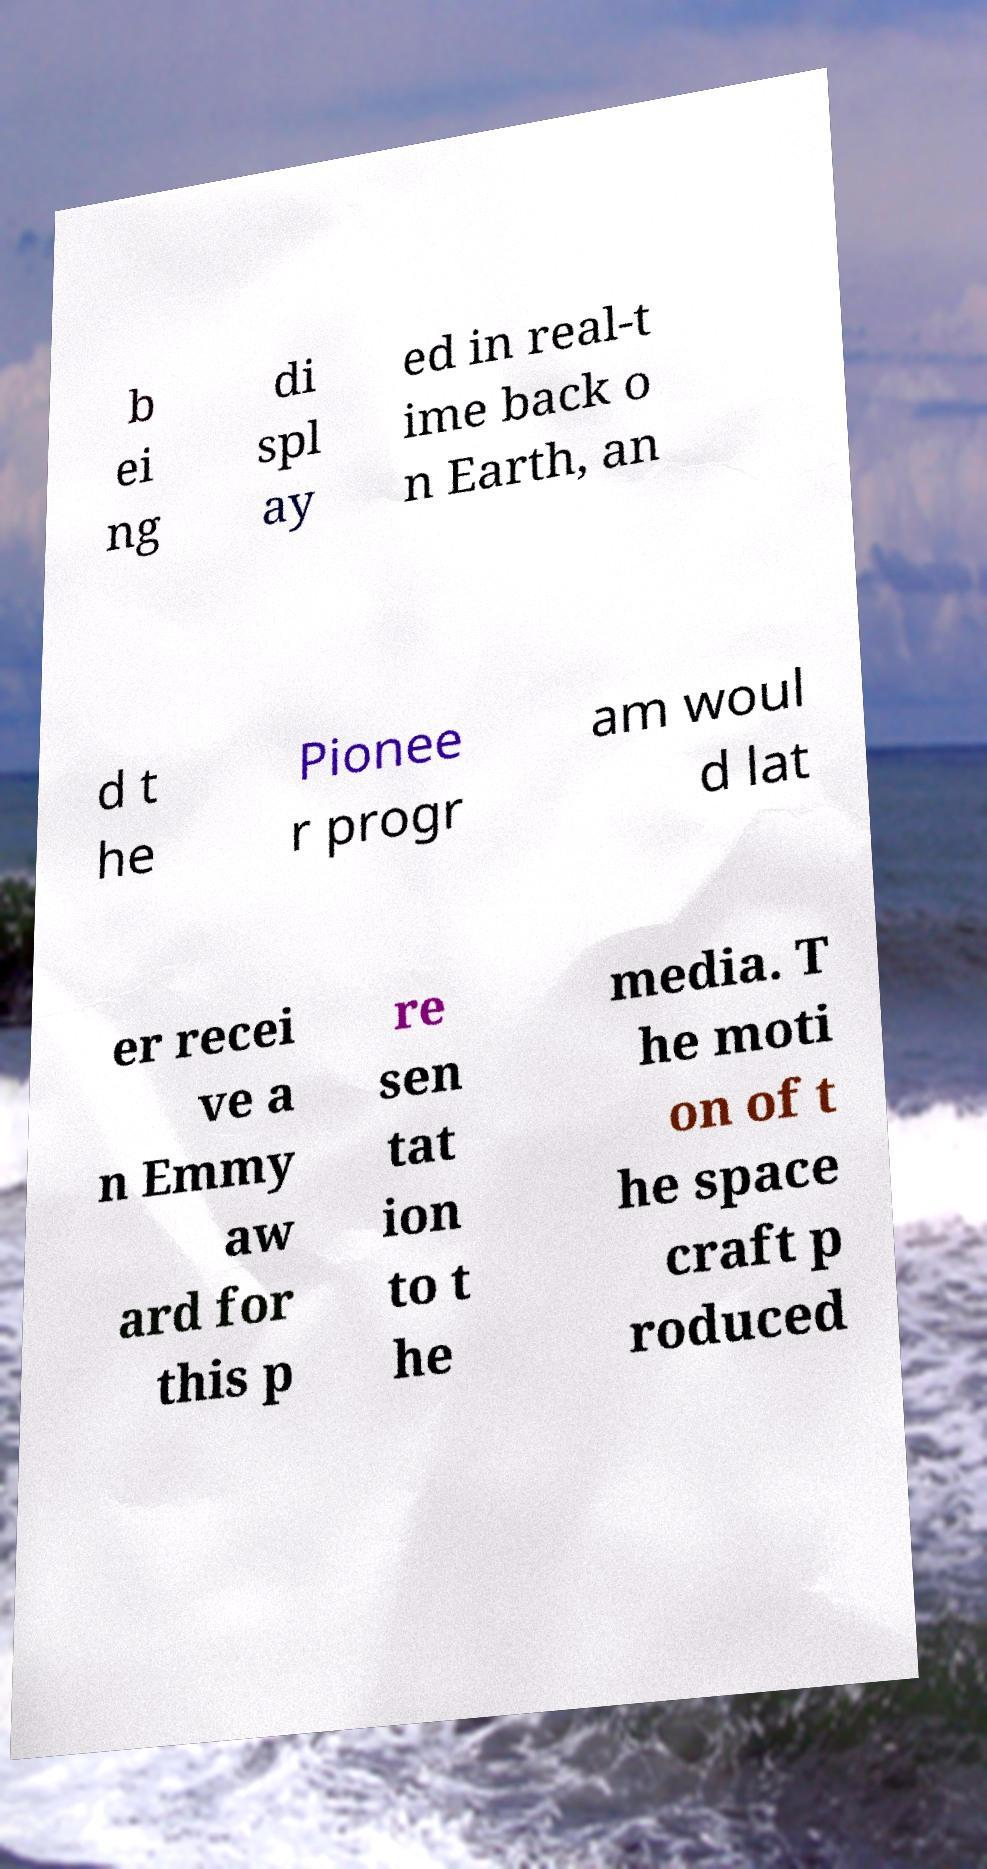For documentation purposes, I need the text within this image transcribed. Could you provide that? b ei ng di spl ay ed in real-t ime back o n Earth, an d t he Pionee r progr am woul d lat er recei ve a n Emmy aw ard for this p re sen tat ion to t he media. T he moti on of t he space craft p roduced 